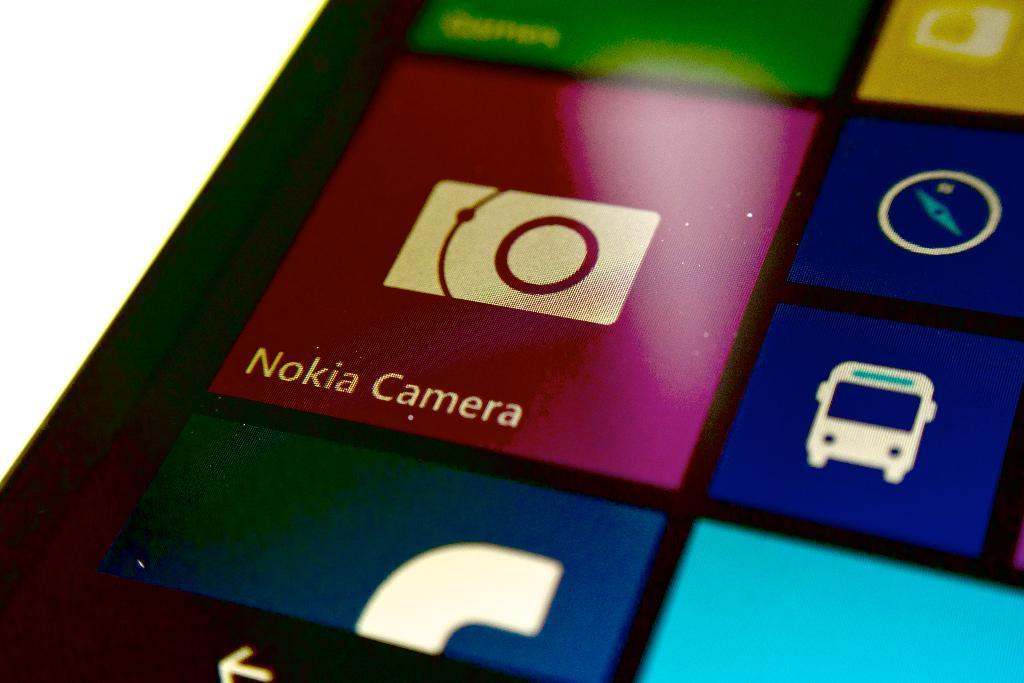<image>
Create a compact narrative representing the image presented. the words Nokia camera that are on the phone 